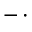Convert formula to latex. <formula><loc_0><loc_0><loc_500><loc_500>- \, \cdot</formula> 